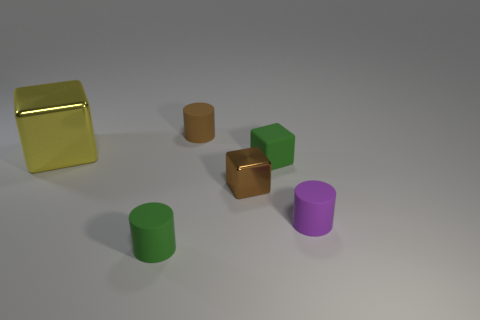Add 1 small rubber cylinders. How many objects exist? 7 Add 3 green metallic blocks. How many green metallic blocks exist? 3 Subtract 0 yellow cylinders. How many objects are left? 6 Subtract all green cylinders. Subtract all shiny objects. How many objects are left? 3 Add 5 brown cylinders. How many brown cylinders are left? 6 